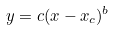Convert formula to latex. <formula><loc_0><loc_0><loc_500><loc_500>y = c ( x - x _ { c } ) ^ { b }</formula> 